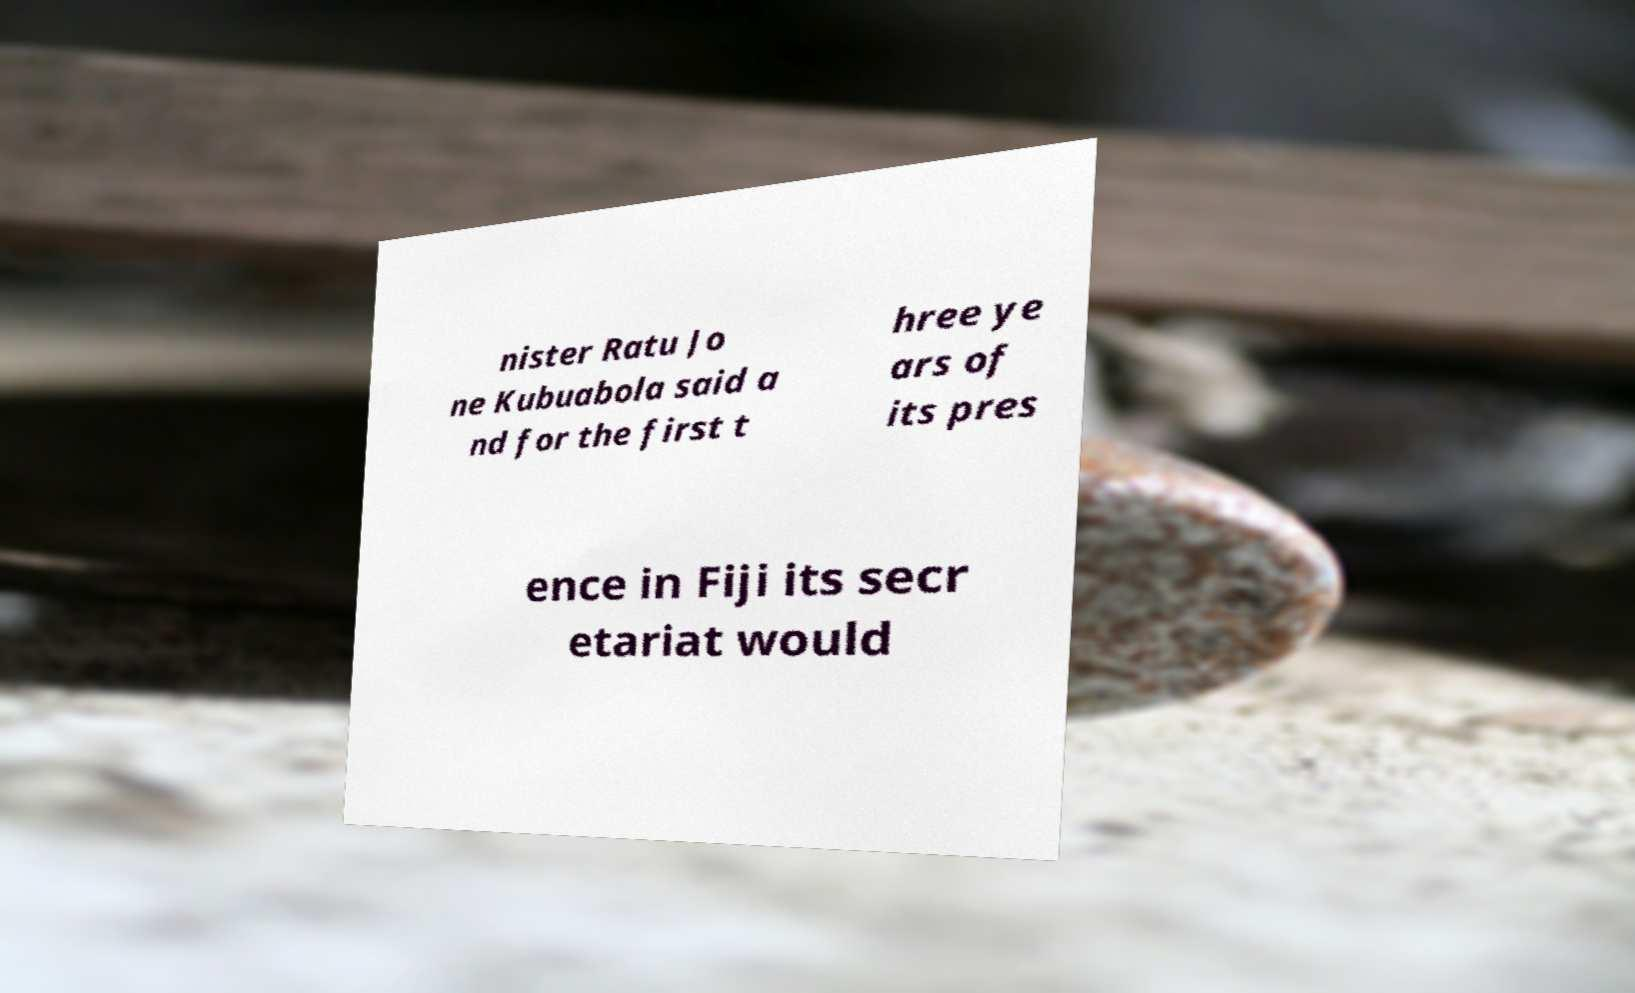Could you assist in decoding the text presented in this image and type it out clearly? nister Ratu Jo ne Kubuabola said a nd for the first t hree ye ars of its pres ence in Fiji its secr etariat would 